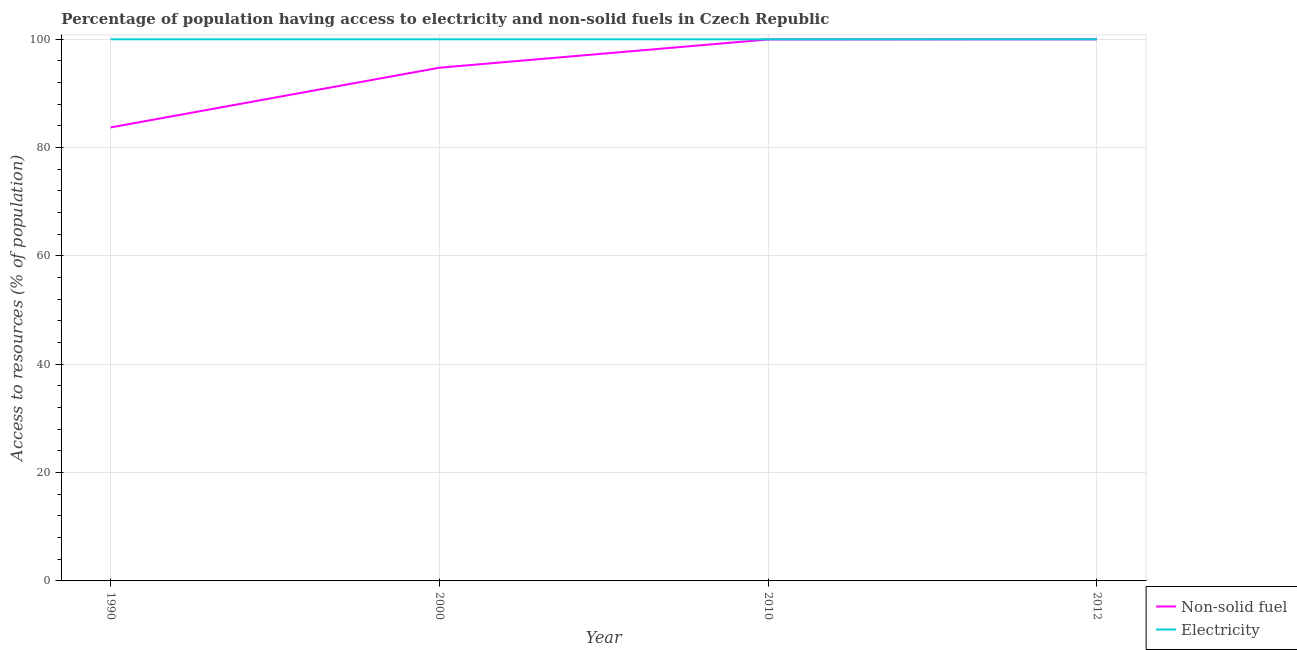Is the number of lines equal to the number of legend labels?
Make the answer very short. Yes. What is the percentage of population having access to electricity in 2000?
Your answer should be compact. 100. Across all years, what is the maximum percentage of population having access to electricity?
Your response must be concise. 100. Across all years, what is the minimum percentage of population having access to non-solid fuel?
Ensure brevity in your answer.  83.73. In which year was the percentage of population having access to non-solid fuel maximum?
Provide a succinct answer. 2012. What is the total percentage of population having access to electricity in the graph?
Your response must be concise. 400. What is the difference between the percentage of population having access to non-solid fuel in 2010 and the percentage of population having access to electricity in 2012?
Your answer should be very brief. -0.04. What is the average percentage of population having access to non-solid fuel per year?
Provide a succinct answer. 94.61. In the year 2000, what is the difference between the percentage of population having access to non-solid fuel and percentage of population having access to electricity?
Your response must be concise. -5.25. What is the ratio of the percentage of population having access to electricity in 2000 to that in 2012?
Offer a very short reply. 1. Is the percentage of population having access to non-solid fuel in 1990 less than that in 2010?
Your answer should be very brief. Yes. Is the difference between the percentage of population having access to electricity in 2000 and 2010 greater than the difference between the percentage of population having access to non-solid fuel in 2000 and 2010?
Give a very brief answer. Yes. In how many years, is the percentage of population having access to non-solid fuel greater than the average percentage of population having access to non-solid fuel taken over all years?
Ensure brevity in your answer.  3. Is the sum of the percentage of population having access to non-solid fuel in 2000 and 2012 greater than the maximum percentage of population having access to electricity across all years?
Your answer should be very brief. Yes. Is the percentage of population having access to electricity strictly greater than the percentage of population having access to non-solid fuel over the years?
Give a very brief answer. Yes. Is the percentage of population having access to electricity strictly less than the percentage of population having access to non-solid fuel over the years?
Provide a short and direct response. No. How many lines are there?
Keep it short and to the point. 2. What is the difference between two consecutive major ticks on the Y-axis?
Offer a terse response. 20. Does the graph contain grids?
Keep it short and to the point. Yes. How many legend labels are there?
Your answer should be very brief. 2. What is the title of the graph?
Your answer should be compact. Percentage of population having access to electricity and non-solid fuels in Czech Republic. What is the label or title of the Y-axis?
Your answer should be compact. Access to resources (% of population). What is the Access to resources (% of population) in Non-solid fuel in 1990?
Make the answer very short. 83.73. What is the Access to resources (% of population) of Electricity in 1990?
Your answer should be very brief. 100. What is the Access to resources (% of population) of Non-solid fuel in 2000?
Offer a terse response. 94.75. What is the Access to resources (% of population) in Non-solid fuel in 2010?
Offer a terse response. 99.96. What is the Access to resources (% of population) of Electricity in 2010?
Provide a succinct answer. 100. What is the Access to resources (% of population) in Non-solid fuel in 2012?
Provide a succinct answer. 99.99. What is the Access to resources (% of population) in Electricity in 2012?
Provide a succinct answer. 100. Across all years, what is the maximum Access to resources (% of population) in Non-solid fuel?
Keep it short and to the point. 99.99. Across all years, what is the minimum Access to resources (% of population) in Non-solid fuel?
Provide a succinct answer. 83.73. What is the total Access to resources (% of population) of Non-solid fuel in the graph?
Provide a succinct answer. 378.43. What is the total Access to resources (% of population) of Electricity in the graph?
Provide a short and direct response. 400. What is the difference between the Access to resources (% of population) in Non-solid fuel in 1990 and that in 2000?
Your response must be concise. -11.02. What is the difference between the Access to resources (% of population) in Non-solid fuel in 1990 and that in 2010?
Ensure brevity in your answer.  -16.24. What is the difference between the Access to resources (% of population) of Electricity in 1990 and that in 2010?
Make the answer very short. 0. What is the difference between the Access to resources (% of population) in Non-solid fuel in 1990 and that in 2012?
Your response must be concise. -16.26. What is the difference between the Access to resources (% of population) of Electricity in 1990 and that in 2012?
Make the answer very short. 0. What is the difference between the Access to resources (% of population) of Non-solid fuel in 2000 and that in 2010?
Provide a short and direct response. -5.21. What is the difference between the Access to resources (% of population) in Non-solid fuel in 2000 and that in 2012?
Your response must be concise. -5.24. What is the difference between the Access to resources (% of population) in Non-solid fuel in 2010 and that in 2012?
Ensure brevity in your answer.  -0.03. What is the difference between the Access to resources (% of population) in Non-solid fuel in 1990 and the Access to resources (% of population) in Electricity in 2000?
Your answer should be compact. -16.27. What is the difference between the Access to resources (% of population) of Non-solid fuel in 1990 and the Access to resources (% of population) of Electricity in 2010?
Provide a short and direct response. -16.27. What is the difference between the Access to resources (% of population) in Non-solid fuel in 1990 and the Access to resources (% of population) in Electricity in 2012?
Your answer should be compact. -16.27. What is the difference between the Access to resources (% of population) in Non-solid fuel in 2000 and the Access to resources (% of population) in Electricity in 2010?
Your answer should be compact. -5.25. What is the difference between the Access to resources (% of population) of Non-solid fuel in 2000 and the Access to resources (% of population) of Electricity in 2012?
Your answer should be compact. -5.25. What is the difference between the Access to resources (% of population) of Non-solid fuel in 2010 and the Access to resources (% of population) of Electricity in 2012?
Keep it short and to the point. -0.04. What is the average Access to resources (% of population) in Non-solid fuel per year?
Offer a terse response. 94.61. What is the average Access to resources (% of population) of Electricity per year?
Provide a succinct answer. 100. In the year 1990, what is the difference between the Access to resources (% of population) of Non-solid fuel and Access to resources (% of population) of Electricity?
Your answer should be very brief. -16.27. In the year 2000, what is the difference between the Access to resources (% of population) in Non-solid fuel and Access to resources (% of population) in Electricity?
Offer a terse response. -5.25. In the year 2010, what is the difference between the Access to resources (% of population) in Non-solid fuel and Access to resources (% of population) in Electricity?
Give a very brief answer. -0.04. In the year 2012, what is the difference between the Access to resources (% of population) in Non-solid fuel and Access to resources (% of population) in Electricity?
Your answer should be very brief. -0.01. What is the ratio of the Access to resources (% of population) in Non-solid fuel in 1990 to that in 2000?
Your answer should be compact. 0.88. What is the ratio of the Access to resources (% of population) of Electricity in 1990 to that in 2000?
Your answer should be very brief. 1. What is the ratio of the Access to resources (% of population) of Non-solid fuel in 1990 to that in 2010?
Ensure brevity in your answer.  0.84. What is the ratio of the Access to resources (% of population) in Electricity in 1990 to that in 2010?
Provide a short and direct response. 1. What is the ratio of the Access to resources (% of population) of Non-solid fuel in 1990 to that in 2012?
Offer a terse response. 0.84. What is the ratio of the Access to resources (% of population) of Electricity in 1990 to that in 2012?
Provide a succinct answer. 1. What is the ratio of the Access to resources (% of population) in Non-solid fuel in 2000 to that in 2010?
Your answer should be compact. 0.95. What is the ratio of the Access to resources (% of population) of Electricity in 2000 to that in 2010?
Keep it short and to the point. 1. What is the ratio of the Access to resources (% of population) of Non-solid fuel in 2000 to that in 2012?
Provide a succinct answer. 0.95. What is the ratio of the Access to resources (% of population) in Non-solid fuel in 2010 to that in 2012?
Ensure brevity in your answer.  1. What is the ratio of the Access to resources (% of population) in Electricity in 2010 to that in 2012?
Your answer should be very brief. 1. What is the difference between the highest and the second highest Access to resources (% of population) of Non-solid fuel?
Give a very brief answer. 0.03. What is the difference between the highest and the second highest Access to resources (% of population) in Electricity?
Keep it short and to the point. 0. What is the difference between the highest and the lowest Access to resources (% of population) in Non-solid fuel?
Make the answer very short. 16.26. 